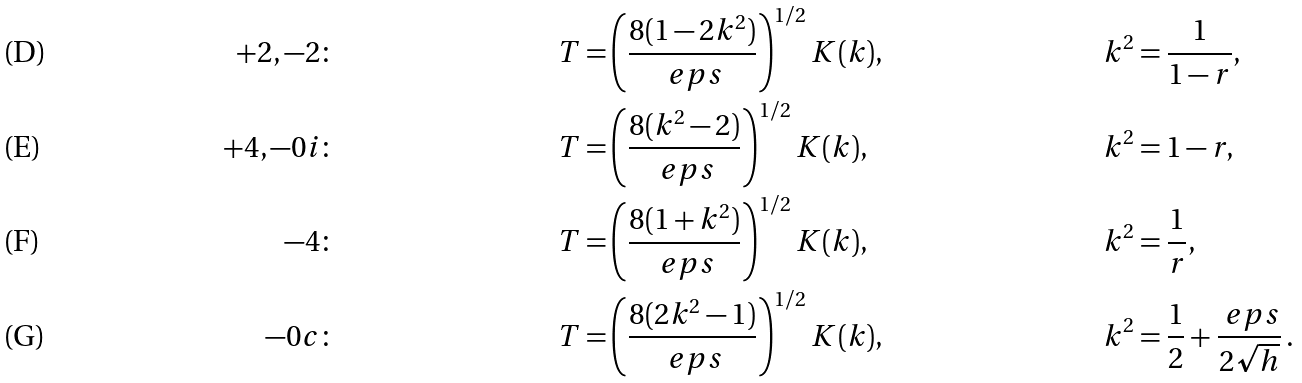<formula> <loc_0><loc_0><loc_500><loc_500>+ 2 , - 2 \colon & & T = & \left ( \frac { 8 ( 1 - 2 k ^ { 2 } ) } { \ e p s } \right ) ^ { 1 / 2 } K ( k ) , & & k ^ { 2 } = \frac { 1 } { 1 - r } , \\ + 4 , - 0 i \colon & & T = & \left ( \frac { 8 ( k ^ { 2 } - 2 ) } { \ e p s } \right ) ^ { 1 / 2 } K ( k ) , & & k ^ { 2 } = 1 - r , \\ - 4 \colon & & T = & \left ( \frac { 8 ( 1 + k ^ { 2 } ) } { \ e p s } \right ) ^ { 1 / 2 } K ( k ) , & & k ^ { 2 } = \frac { 1 } { r } , \\ - 0 c \colon & & T = & \left ( \frac { 8 ( 2 k ^ { 2 } - 1 ) } { \ e p s } \right ) ^ { 1 / 2 } K ( k ) , & & k ^ { 2 } = \frac { 1 } { 2 } + \frac { \ e p s } { 2 \sqrt { h } } \, .</formula> 